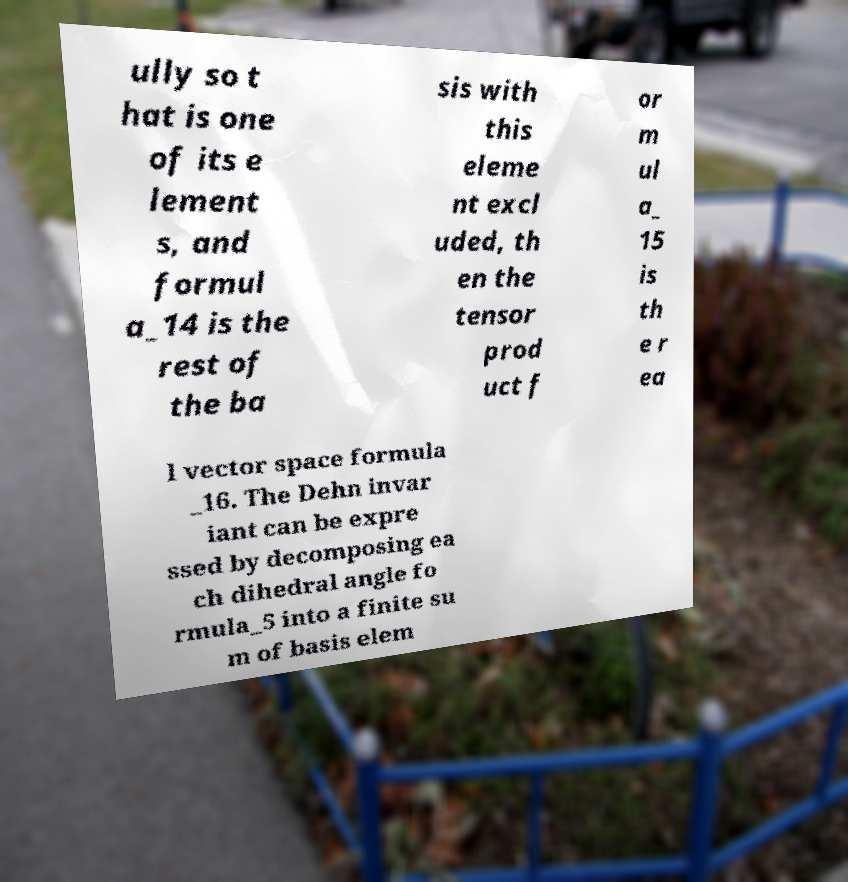For documentation purposes, I need the text within this image transcribed. Could you provide that? ully so t hat is one of its e lement s, and formul a_14 is the rest of the ba sis with this eleme nt excl uded, th en the tensor prod uct f or m ul a_ 15 is th e r ea l vector space formula _16. The Dehn invar iant can be expre ssed by decomposing ea ch dihedral angle fo rmula_5 into a finite su m of basis elem 